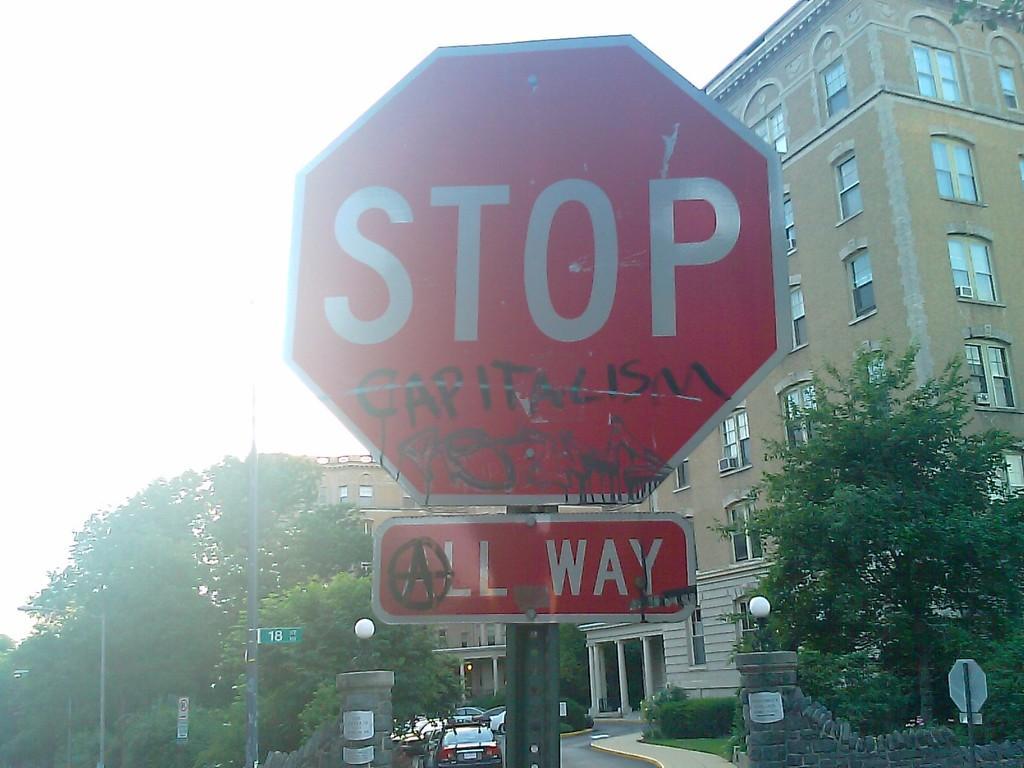Please provide a concise description of this image. In this picture we can see a STOP signboard on a pole. There are a few boards on the poles. We can see vehicles on the road. There are trees on the left and right side of the image. We can see a building in the background. 